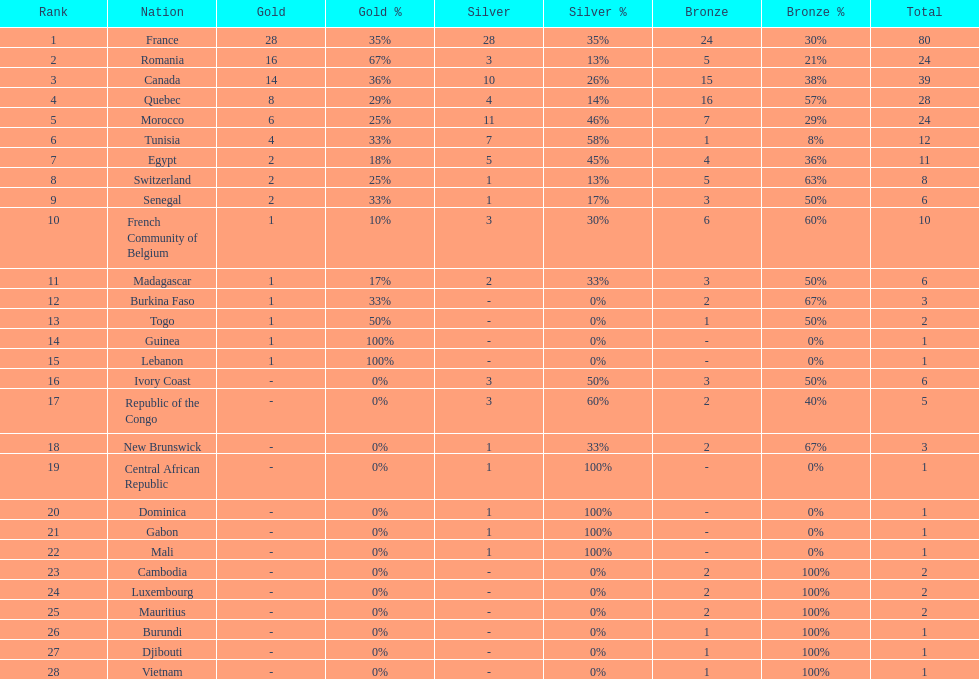How many bronze medals does togo have? 1. 